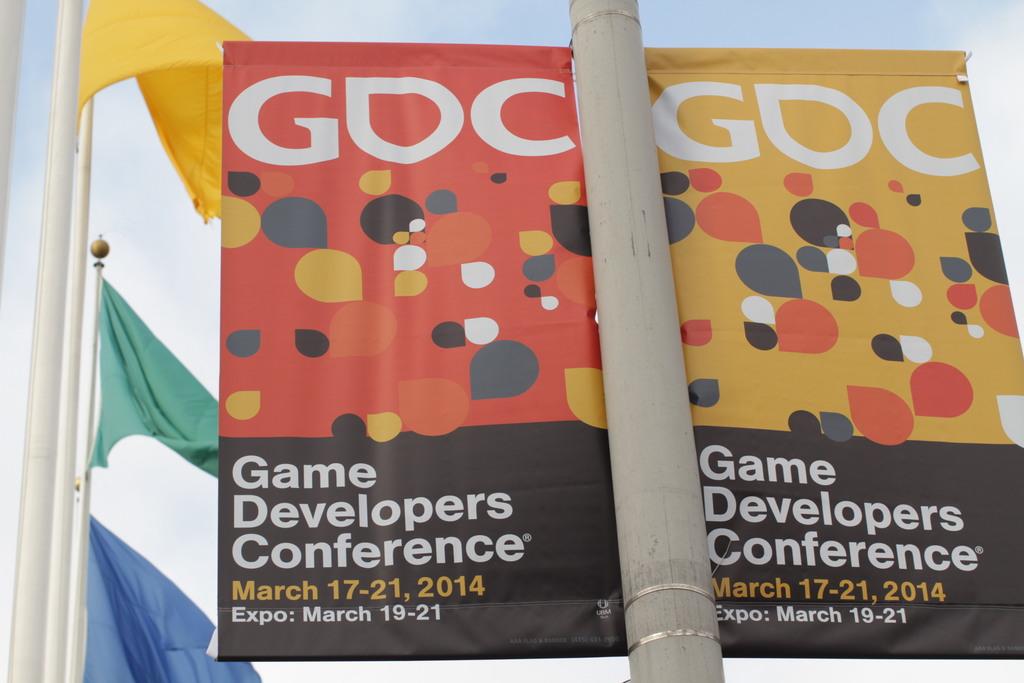What kind of conference is this?
Keep it short and to the point. Game developers. 